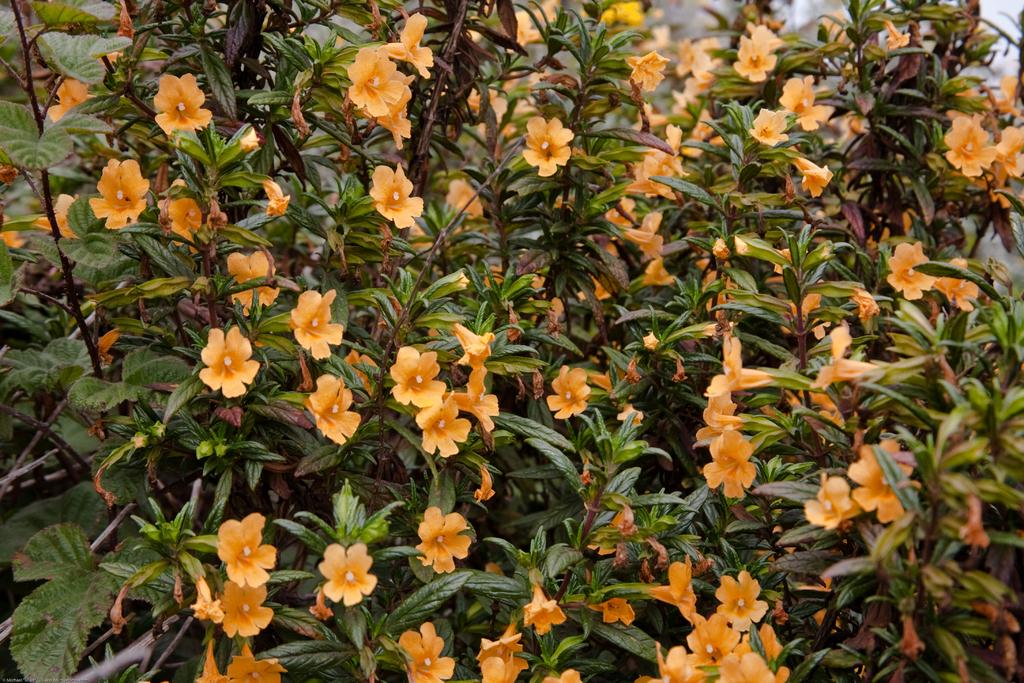What type of living organisms can be seen in the image? Plants can be seen in the image. What additional features can be observed on the plants? The plants have flowers. What type of pet can be seen playing with a goat in the basket in the image? There is no pet, goat, or basket present in the image; it only features plants with flowers. 